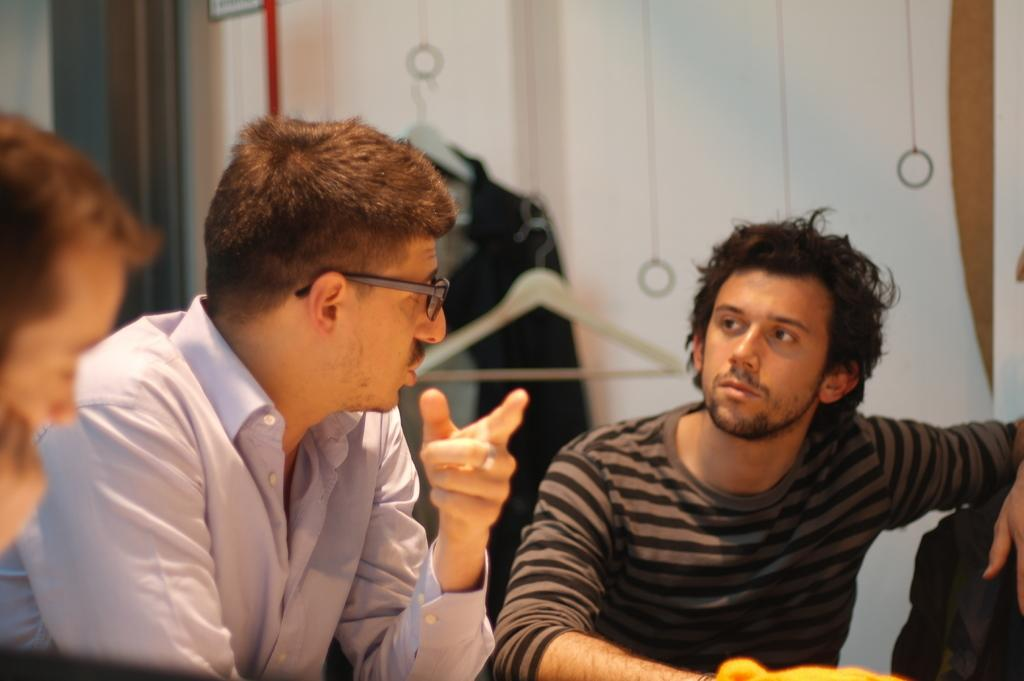What are the people in the image doing? There is a group of people sitting in the image. What can be seen hanging on a hanger in the image? There is a suit hanging on a hanger in the image. What is visible in the background of the image? There is a wall visible in the image. Where is the drain located in the image? There is no drain present in the image. Can you describe the girl sitting in the image? There is no girl present in the image; it only shows a group of people sitting. 